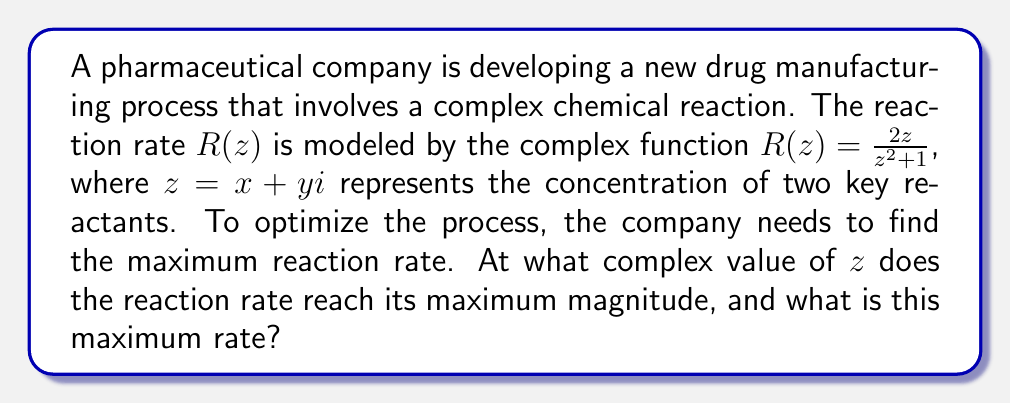What is the answer to this math problem? To solve this problem, we'll use complex analysis techniques:

1) First, we need to find the critical points of $R(z)$. These occur where $R'(z) = 0$ or where $R(z)$ is undefined.

2) The derivative of $R(z)$ is:
   $$R'(z) = \frac{2(z^2+1) - 2z(2z)}{(z^2+1)^2} = \frac{2-2z^2}{(z^2+1)^2}$$

3) Setting $R'(z) = 0$:
   $$\frac{2-2z^2}{(z^2+1)^2} = 0$$
   $$2-2z^2 = 0$$
   $$z^2 = 1$$
   $$z = \pm 1$$

4) $R(z)$ is undefined when $z^2 + 1 = 0$, which occurs when $z = \pm i$.

5) Now we need to evaluate $|R(z)|$ at these critical points:
   At $z = 1$: $|R(1)| = |\frac{2}{2}| = 1$
   At $z = -1$: $|R(-1)| = |\frac{-2}{2}| = 1$
   At $z = i$: $R(i)$ is undefined
   At $z = -i$: $R(-i)$ is undefined

6) The maximum magnitude occurs at both $z = 1$ and $z = -1$, with a value of 1.

7) To choose between these, we can consider the physical interpretation: since $z$ represents concentrations, which are typically non-negative, $z = 1$ is the more relevant solution in this context.
Answer: $z = 1$, $|R(1)| = 1$ 